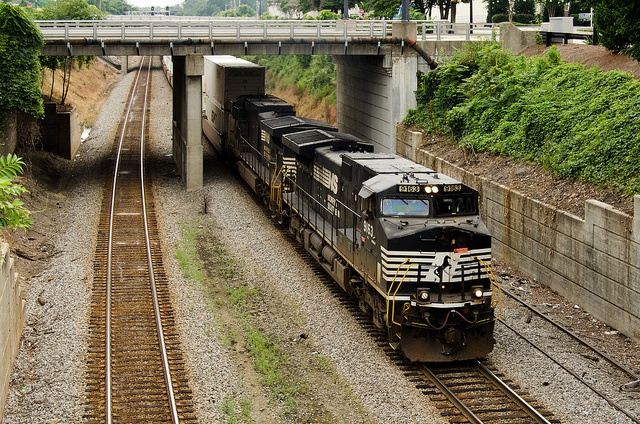Describe the objects in this image and their specific colors. I can see a train in darkgray, black, and gray tones in this image. 